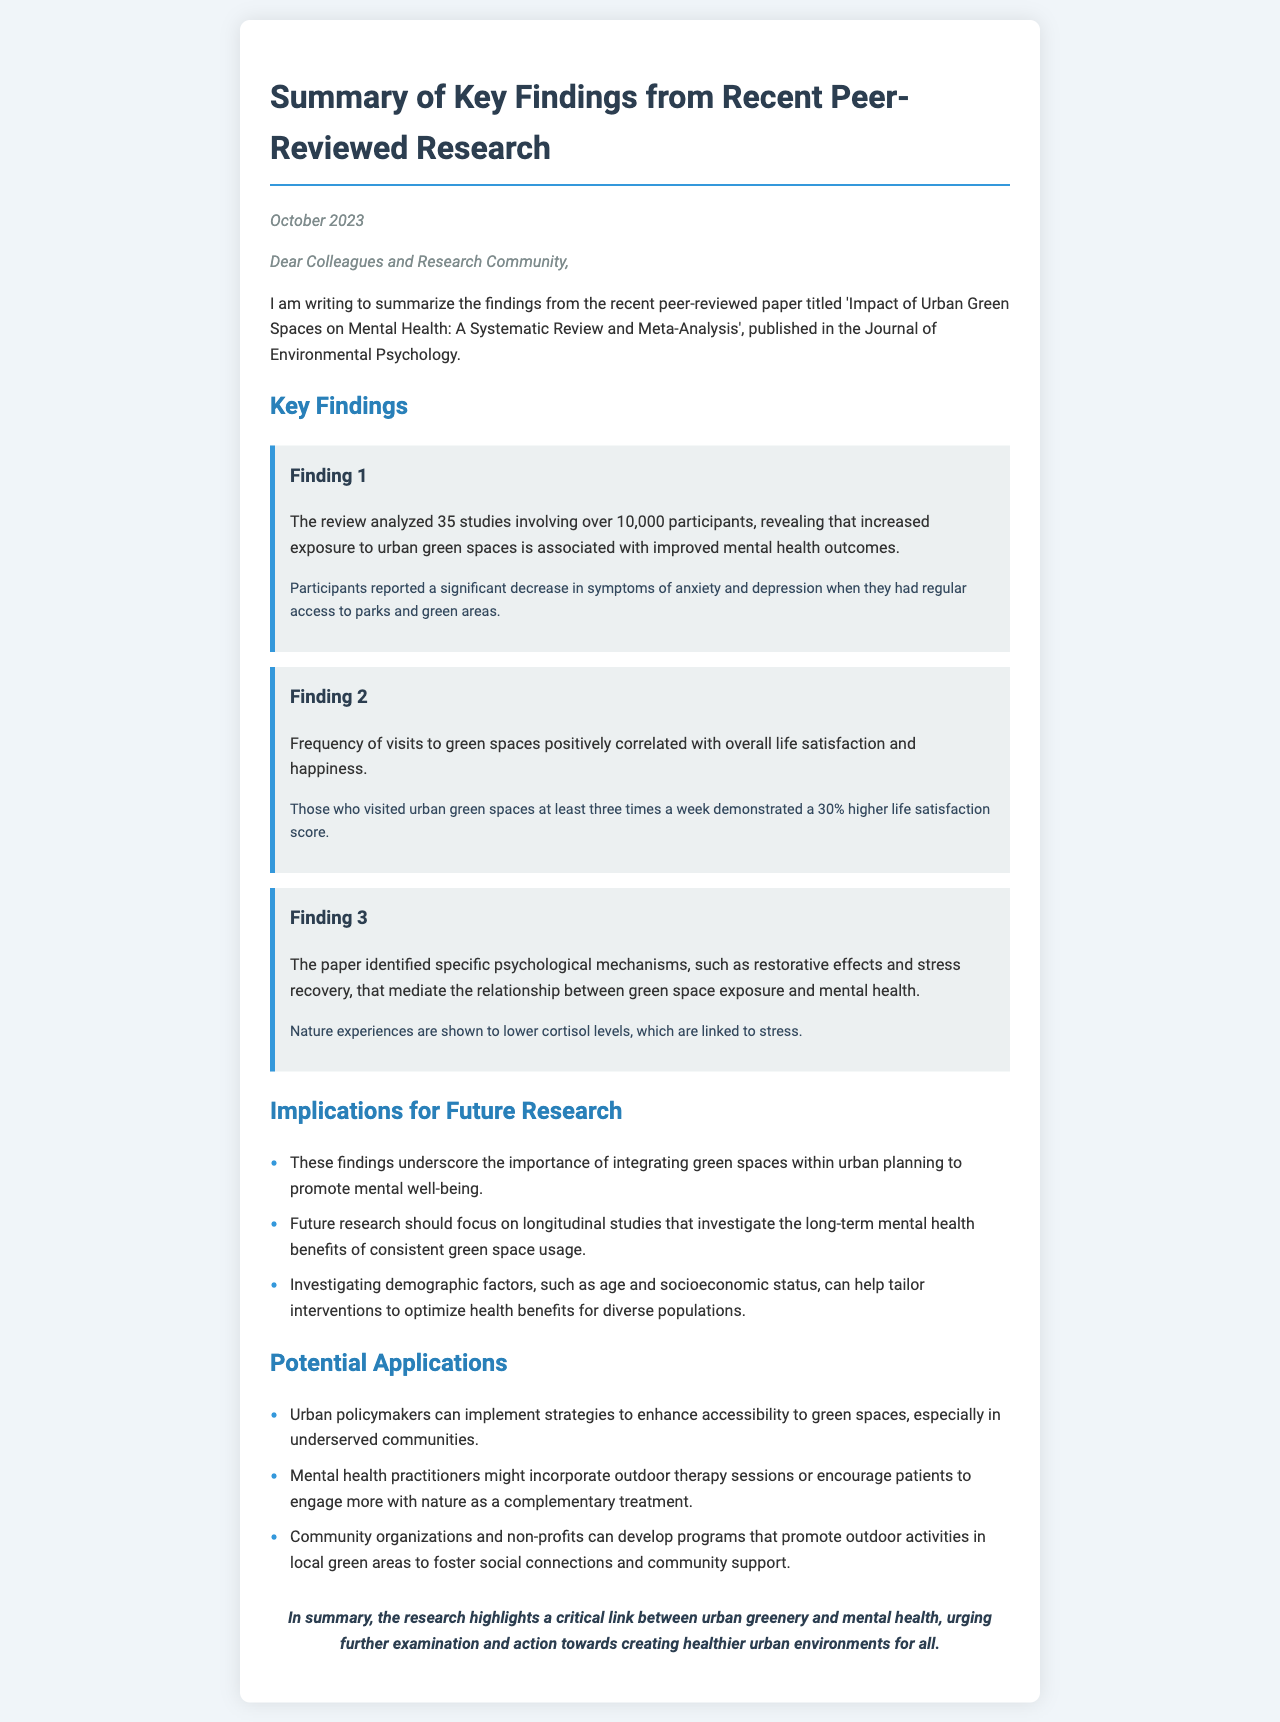what is the title of the paper? The title of the paper is given in the document, which summarizes the research findings related to urban green spaces and mental health.
Answer: Impact of Urban Green Spaces on Mental Health: A Systematic Review and Meta-Analysis how many studies were analyzed in the review? The document states the specific number of studies included in the analysis of the peer-reviewed paper.
Answer: 35 studies what was the total number of participants in the studies? The document provides information about the number of participants involved in the research, which is a key aspect of the findings.
Answer: over 10,000 participants what percentage higher was life satisfaction for those visiting green spaces at least three times a week? The document mentions a specific percentage related to life satisfaction scores among a certain group of participants.
Answer: 30% what specific psychological mechanisms were identified in the paper? The document lists psychological mechanisms mediating the relationship between green space exposure and mental health as highlighted in the findings.
Answer: restorative effects and stress recovery what should future research focus on according to the implications? The document discusses areas for further investigation after assessing the key findings from the research paper.
Answer: longitudinal studies what is one potential application for urban policymakers? The document outlines practical applications based on the research findings that could benefit urban planning and community health.
Answer: enhance accessibility to green spaces what is the conclusion of the research summary? The document concludes the summary by stating the overall significance of the research findings on urban greenery and mental health.
Answer: critical link between urban greenery and mental health 